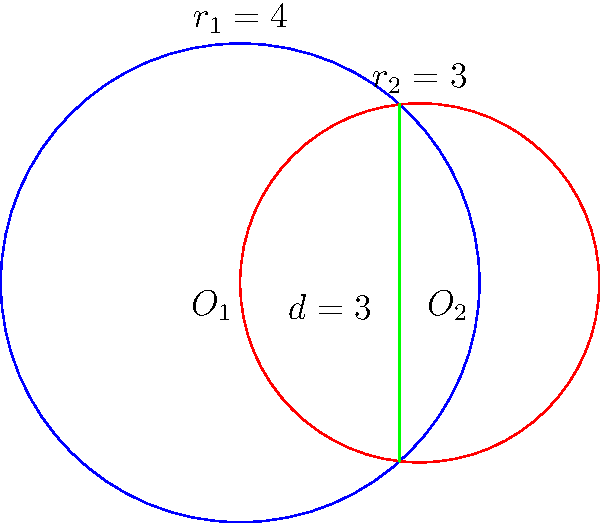Two circles intersect as shown in the figure. The radii of the circles are $r_1 = 4$ and $r_2 = 3$, and the distance between their centers is $d = 3$. Calculate the area of the region between the two circles, representing the spiritual space where two souls overlap. Express your answer in terms of $\pi$. To find the area between the two circles, we need to:

1. Calculate the area of each circular segment.
2. Subtract these areas from the total area of both circles.

Step 1: Find the central angles of the segments
Let $\theta_1$ and $\theta_2$ be the central angles of the segments in radians.
Using the cosine law:

$\cos(\frac{\theta_1}{2}) = \frac{d^2 + r_1^2 - r_2^2}{2dr_1} = \frac{3^2 + 4^2 - 3^2}{2 \cdot 3 \cdot 4} = \frac{13}{24}$
$\theta_1 = 2 \arccos(\frac{13}{24}) \approx 2.0944$ radians

$\cos(\frac{\theta_2}{2}) = \frac{d^2 + r_2^2 - r_1^2}{2dr_2} = \frac{3^2 + 3^2 - 4^2}{2 \cdot 3 \cdot 3} = -\frac{1}{6}$
$\theta_2 = 2 \arccos(-\frac{1}{6}) \approx 2.7307$ radians

Step 2: Calculate the areas of the circular segments
Area of segment = $\frac{r^2}{2}(\theta - \sin\theta)$

Segment 1: $A_1 = \frac{4^2}{2}(2.0944 - \sin(2.0944)) \approx 5.0545$
Segment 2: $A_2 = \frac{3^2}{2}(2.7307 - \sin(2.7307)) \approx 4.4587$

Step 3: Calculate the total area between the circles
Total area = Area of circle 1 + Area of circle 2 - 2(Area of segment 1 + Area of segment 2)
$= \pi r_1^2 + \pi r_2^2 - 2(A_1 + A_2)$
$= 16\pi + 9\pi - 2(5.0545 + 4.4587)$
$= 25\pi - 19.0264$
$\approx 59.5796$

Step 4: Express the answer in terms of $\pi$
$59.5796 \approx 18.9548\pi$
Rounding to a simple fraction: $\frac{19\pi}{1}$ or $19\pi$
Answer: $19\pi$ 